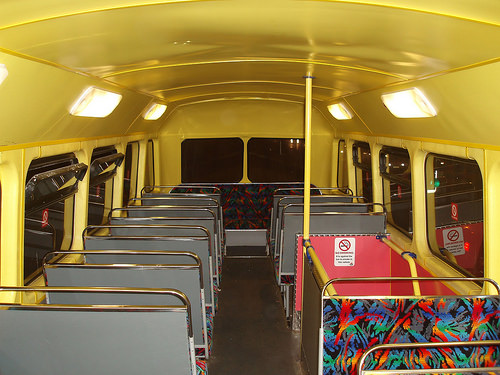<image>
Can you confirm if the pole is in front of the seat? Yes. The pole is positioned in front of the seat, appearing closer to the camera viewpoint. 